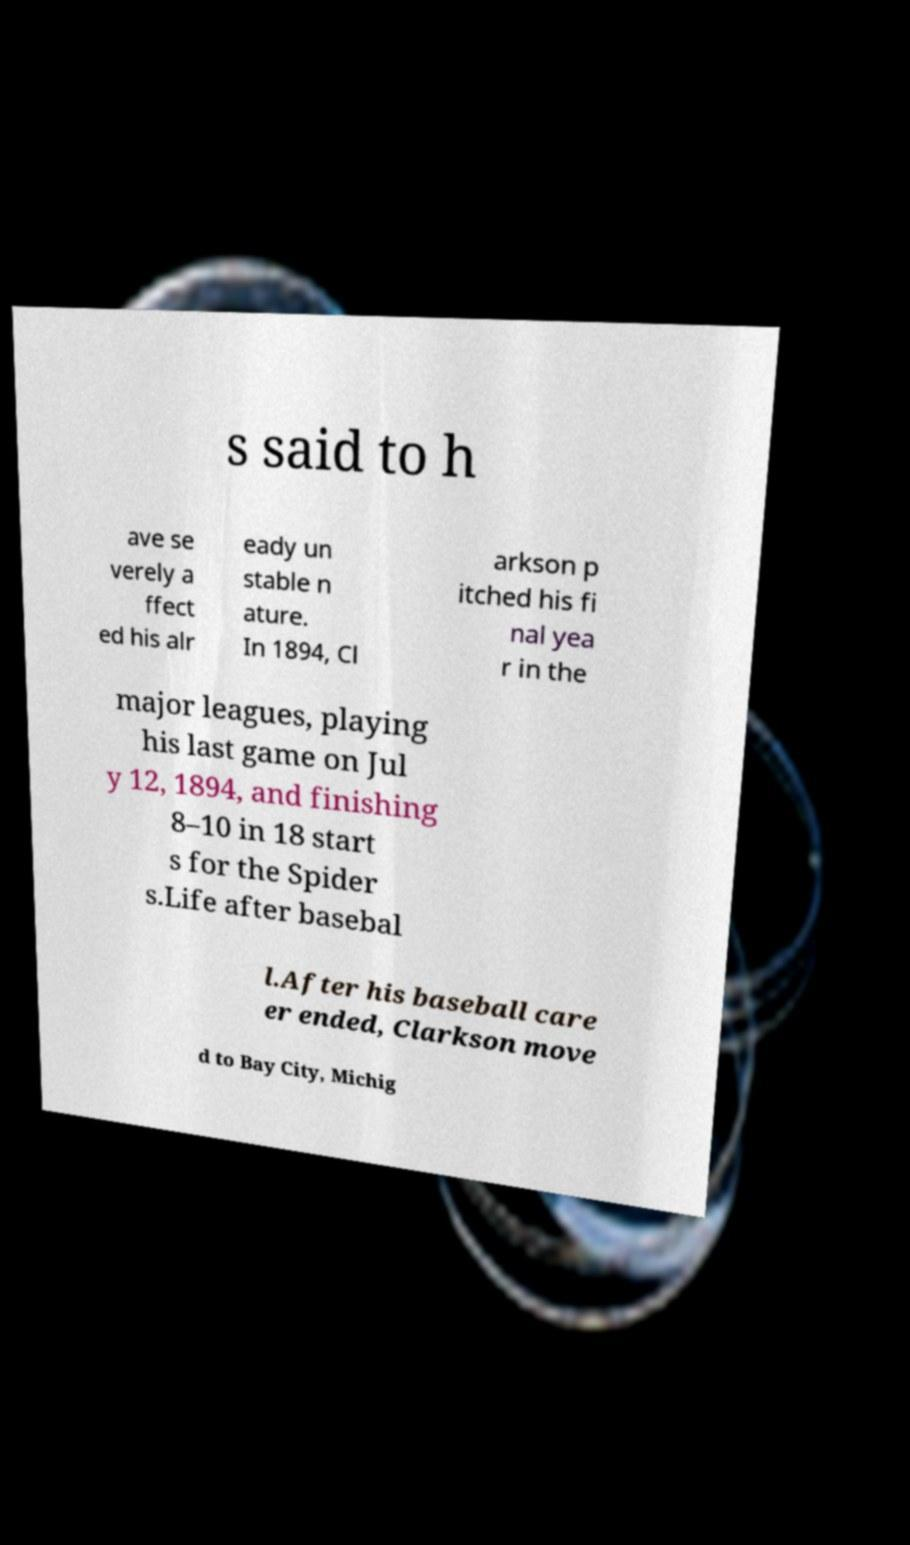Could you assist in decoding the text presented in this image and type it out clearly? s said to h ave se verely a ffect ed his alr eady un stable n ature. In 1894, Cl arkson p itched his fi nal yea r in the major leagues, playing his last game on Jul y 12, 1894, and finishing 8–10 in 18 start s for the Spider s.Life after basebal l.After his baseball care er ended, Clarkson move d to Bay City, Michig 